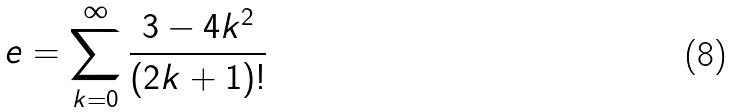<formula> <loc_0><loc_0><loc_500><loc_500>e = \sum _ { k = 0 } ^ { \infty } \frac { 3 - 4 k ^ { 2 } } { ( 2 k + 1 ) ! }</formula> 